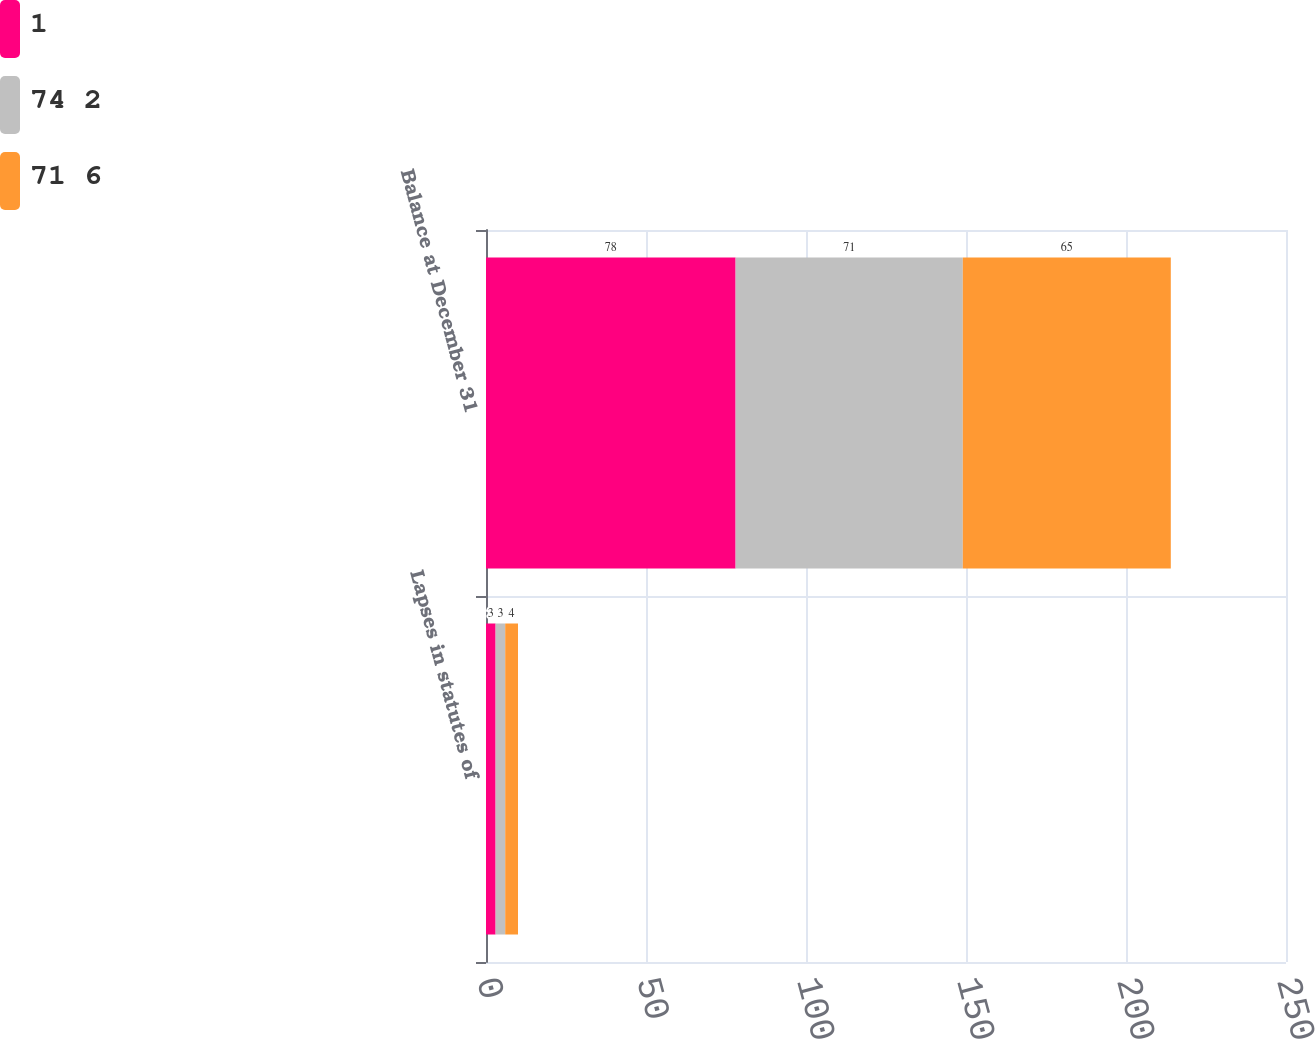<chart> <loc_0><loc_0><loc_500><loc_500><stacked_bar_chart><ecel><fcel>Lapses in statutes of<fcel>Balance at December 31<nl><fcel>1<fcel>3<fcel>78<nl><fcel>74 2<fcel>3<fcel>71<nl><fcel>71 6<fcel>4<fcel>65<nl></chart> 